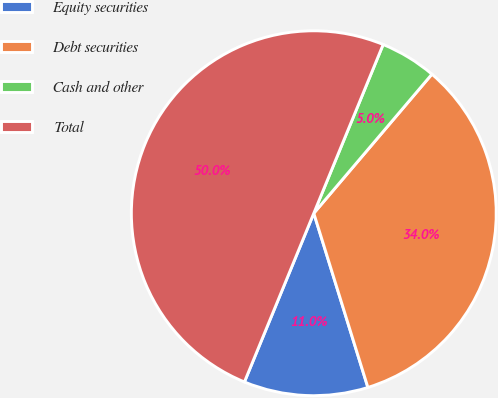Convert chart to OTSL. <chart><loc_0><loc_0><loc_500><loc_500><pie_chart><fcel>Equity securities<fcel>Debt securities<fcel>Cash and other<fcel>Total<nl><fcel>11.0%<fcel>34.0%<fcel>5.0%<fcel>50.0%<nl></chart> 